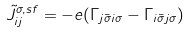<formula> <loc_0><loc_0><loc_500><loc_500>\tilde { J } ^ { \sigma , s f } _ { i j } = - e ( \Gamma _ { j \bar { \sigma } i \sigma } - \Gamma _ { i \bar { \sigma } j \sigma } )</formula> 